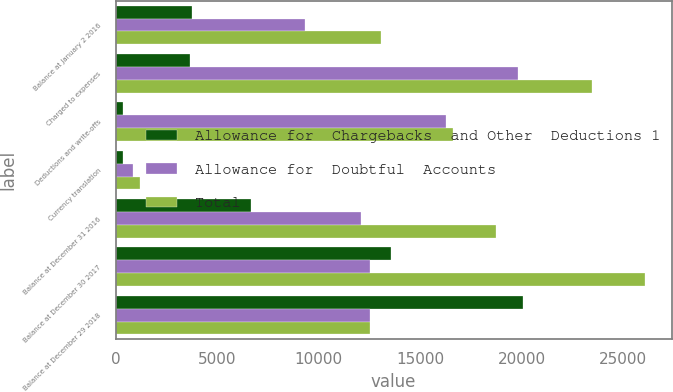Convert chart to OTSL. <chart><loc_0><loc_0><loc_500><loc_500><stacked_bar_chart><ecel><fcel>Balance at January 2 2016<fcel>Charged to expenses<fcel>Deductions and write-offs<fcel>Currency translation<fcel>Balance at December 31 2016<fcel>Balance at December 30 2017<fcel>Balance at December 29 2018<nl><fcel>Allowance for  Chargebacks  and Other  Deductions 1<fcel>3749<fcel>3650<fcel>381<fcel>360<fcel>6658<fcel>13572<fcel>20062<nl><fcel>Allowance for  Doubtful  Accounts<fcel>9351<fcel>19820<fcel>16259<fcel>844<fcel>12068<fcel>12524<fcel>12542<nl><fcel>Total<fcel>13100<fcel>23470<fcel>16640<fcel>1204<fcel>18726<fcel>26096<fcel>12533<nl></chart> 